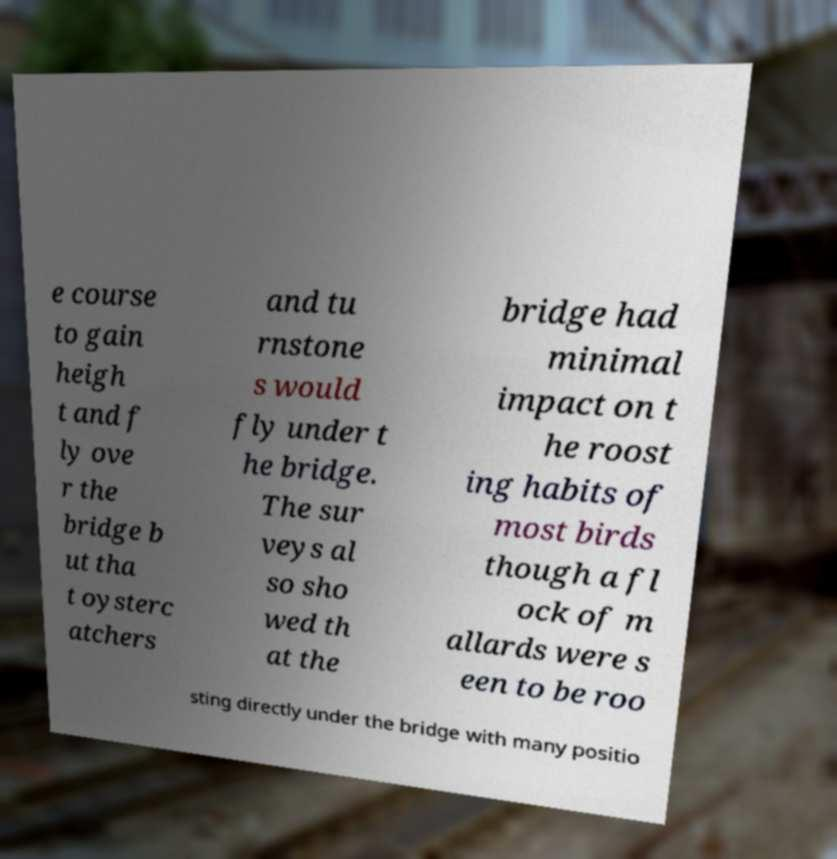Please read and relay the text visible in this image. What does it say? e course to gain heigh t and f ly ove r the bridge b ut tha t oysterc atchers and tu rnstone s would fly under t he bridge. The sur veys al so sho wed th at the bridge had minimal impact on t he roost ing habits of most birds though a fl ock of m allards were s een to be roo sting directly under the bridge with many positio 